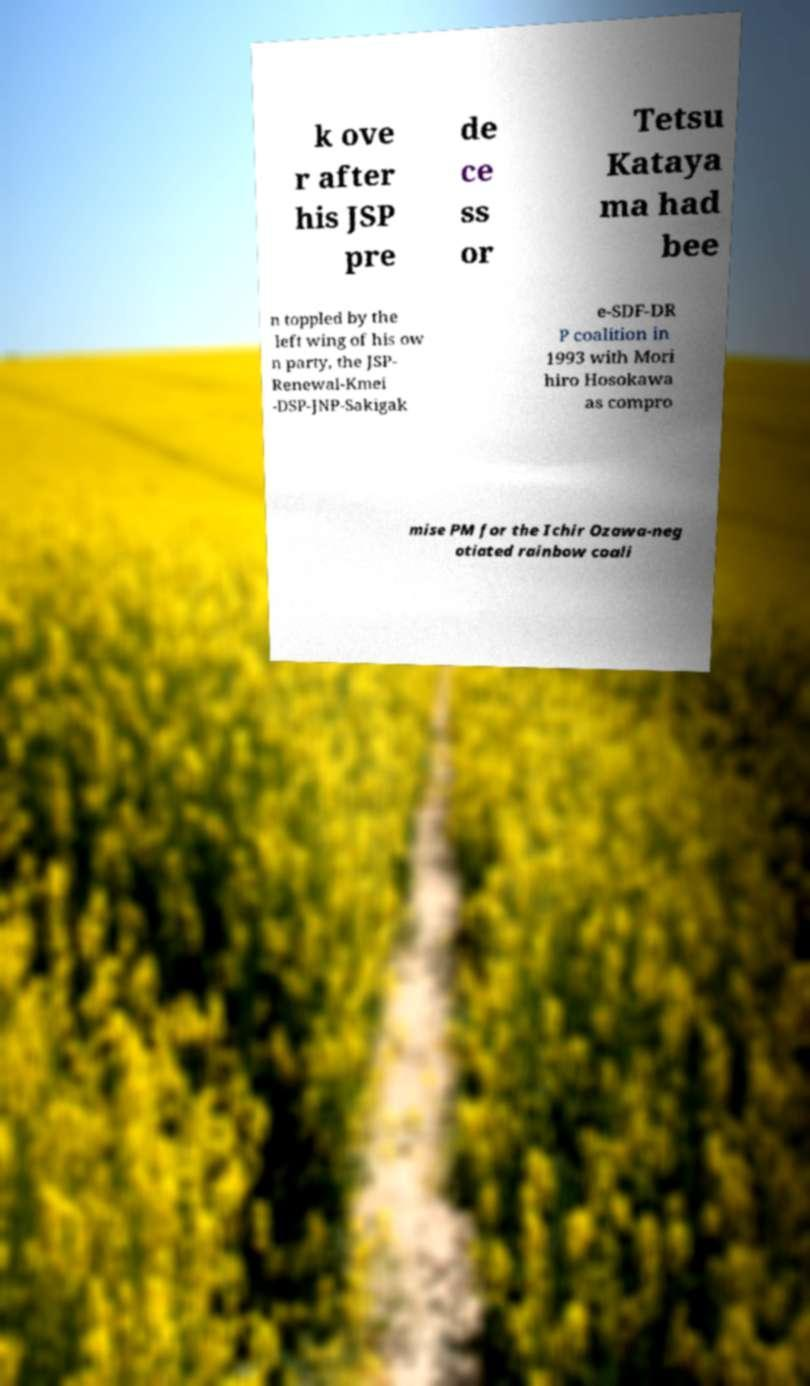Could you assist in decoding the text presented in this image and type it out clearly? k ove r after his JSP pre de ce ss or Tetsu Kataya ma had bee n toppled by the left wing of his ow n party, the JSP- Renewal-Kmei -DSP-JNP-Sakigak e-SDF-DR P coalition in 1993 with Mori hiro Hosokawa as compro mise PM for the Ichir Ozawa-neg otiated rainbow coali 